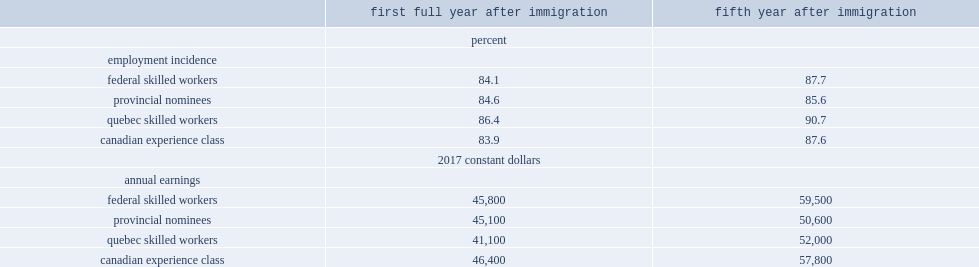Who had lower adjusted earnings in the fifth year, pnp immigrants or fswp immigrants. Provincial nominees. 